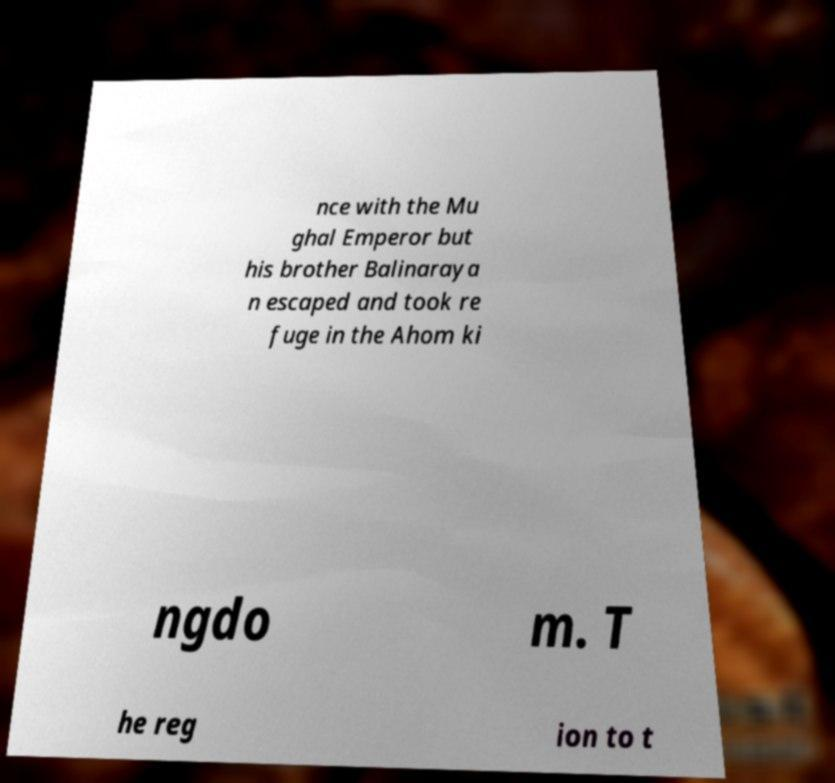Please read and relay the text visible in this image. What does it say? nce with the Mu ghal Emperor but his brother Balinaraya n escaped and took re fuge in the Ahom ki ngdo m. T he reg ion to t 